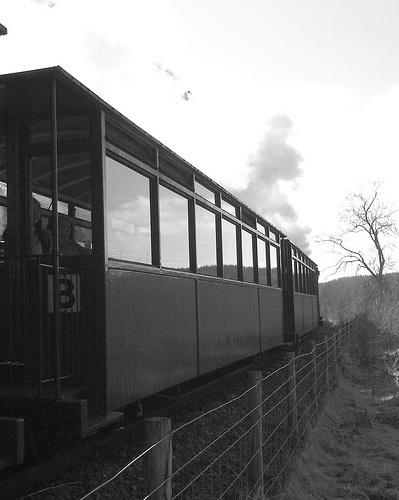What vehicle isn't black? The train in the image is primarily black, but it features certain areas that are not black, such as windows or possibly other decorative elements. 